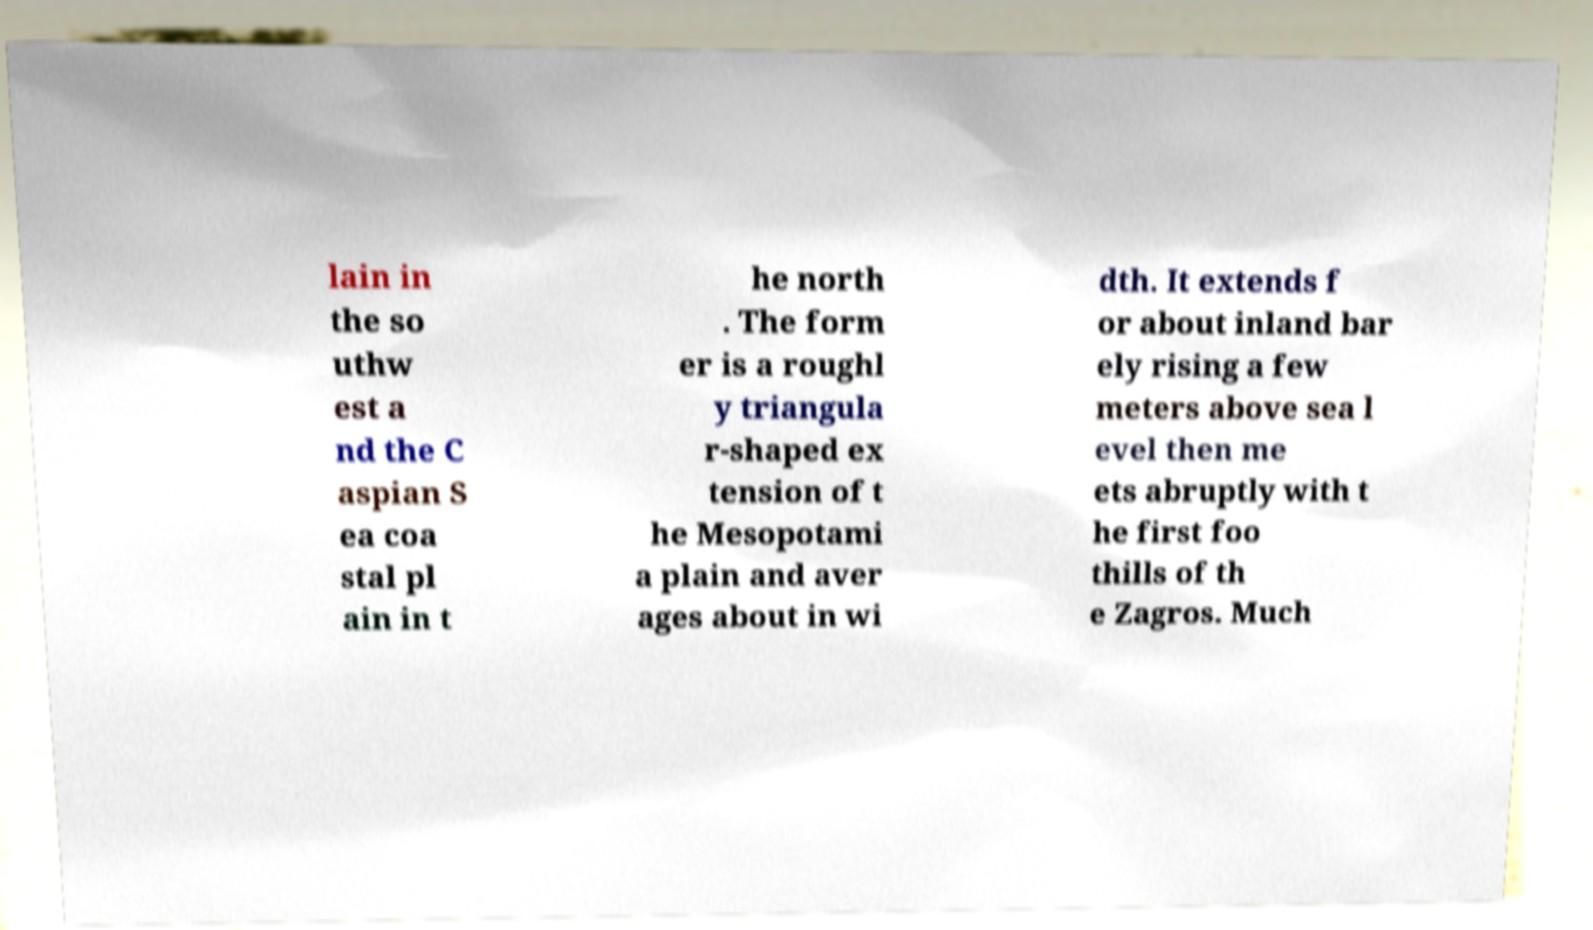Can you accurately transcribe the text from the provided image for me? lain in the so uthw est a nd the C aspian S ea coa stal pl ain in t he north . The form er is a roughl y triangula r-shaped ex tension of t he Mesopotami a plain and aver ages about in wi dth. It extends f or about inland bar ely rising a few meters above sea l evel then me ets abruptly with t he first foo thills of th e Zagros. Much 